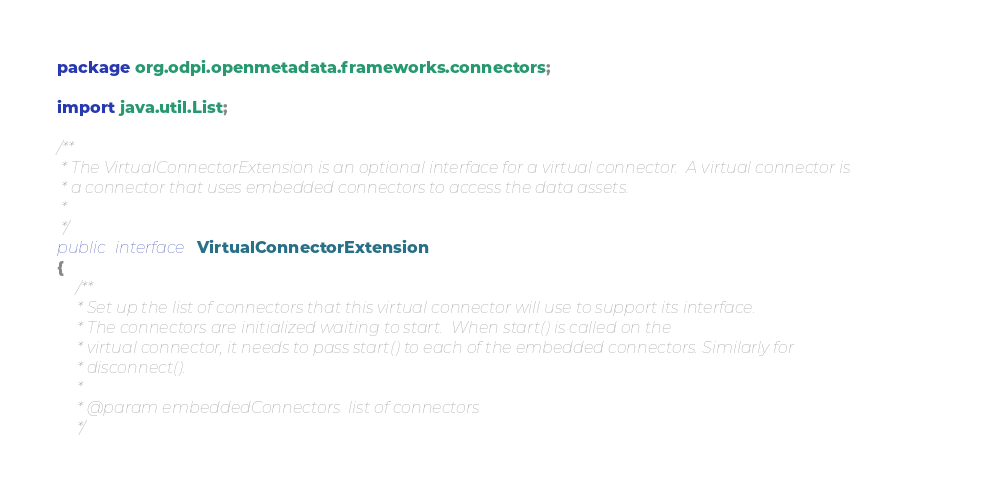Convert code to text. <code><loc_0><loc_0><loc_500><loc_500><_Java_>package org.odpi.openmetadata.frameworks.connectors;

import java.util.List;

/**
 * The VirtualConnectorExtension is an optional interface for a virtual connector.  A virtual connector is
 * a connector that uses embedded connectors to access the data assets.
 *
 */
public interface VirtualConnectorExtension
{
    /**
     * Set up the list of connectors that this virtual connector will use to support its interface.
     * The connectors are initialized waiting to start.  When start() is called on the
     * virtual connector, it needs to pass start() to each of the embedded connectors. Similarly for
     * disconnect().
     *
     * @param embeddedConnectors  list of connectors
     */</code> 